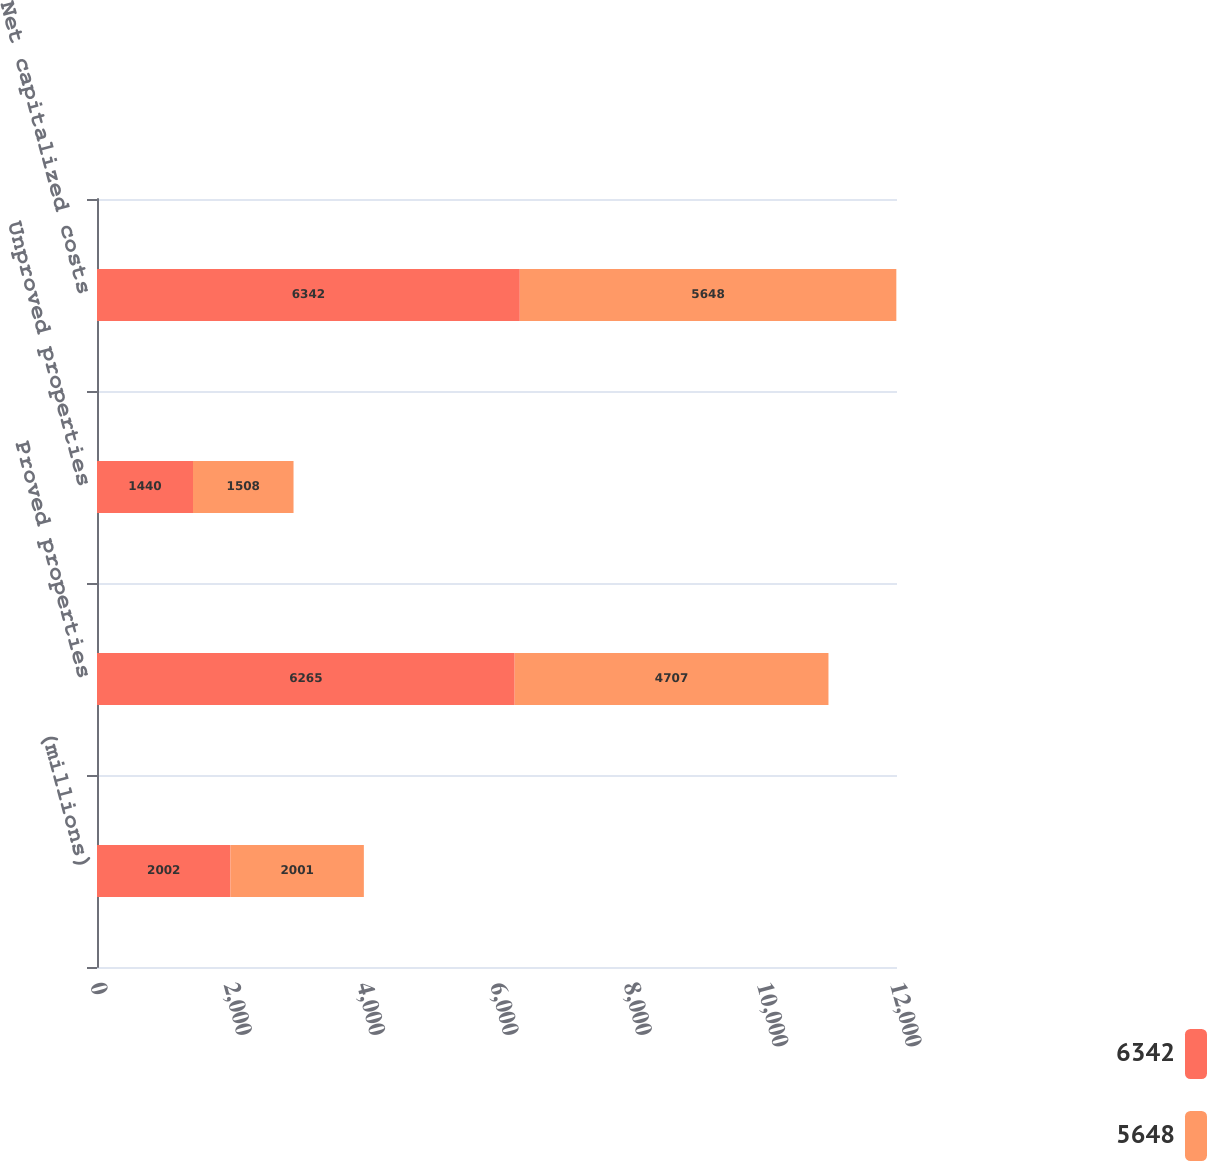Convert chart. <chart><loc_0><loc_0><loc_500><loc_500><stacked_bar_chart><ecel><fcel>(millions)<fcel>Proved properties<fcel>Unproved properties<fcel>Net capitalized costs<nl><fcel>6342<fcel>2002<fcel>6265<fcel>1440<fcel>6342<nl><fcel>5648<fcel>2001<fcel>4707<fcel>1508<fcel>5648<nl></chart> 